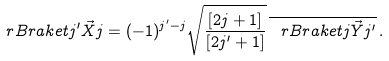<formula> <loc_0><loc_0><loc_500><loc_500>\ r B r a k e t { j ^ { \prime } } { \vec { X } } { j } = ( - 1 ) ^ { j ^ { \prime } - j } \sqrt { \frac { [ 2 j + 1 ] } { [ 2 j ^ { \prime } + 1 ] } } \, \overline { \ r B r a k e t { j } { \vec { Y } } { j ^ { \prime } } } \, .</formula> 